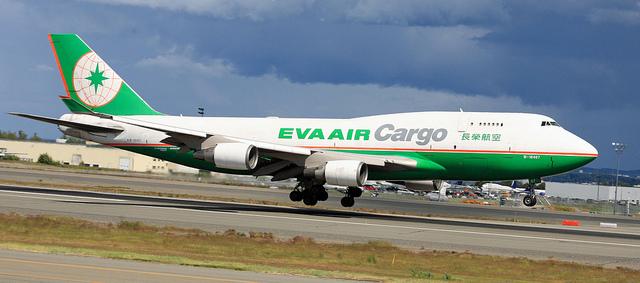What color is this plan?
Keep it brief. White and green. Is this a commercial plane?
Be succinct. Yes. Is the plane landing?
Write a very short answer. Yes. What does the plane have written on it?
Write a very short answer. Eva air cargo. Is the plane parked?
Give a very brief answer. No. Is this airplane flying?
Write a very short answer. Yes. Is the plane in motion?
Be succinct. Yes. 